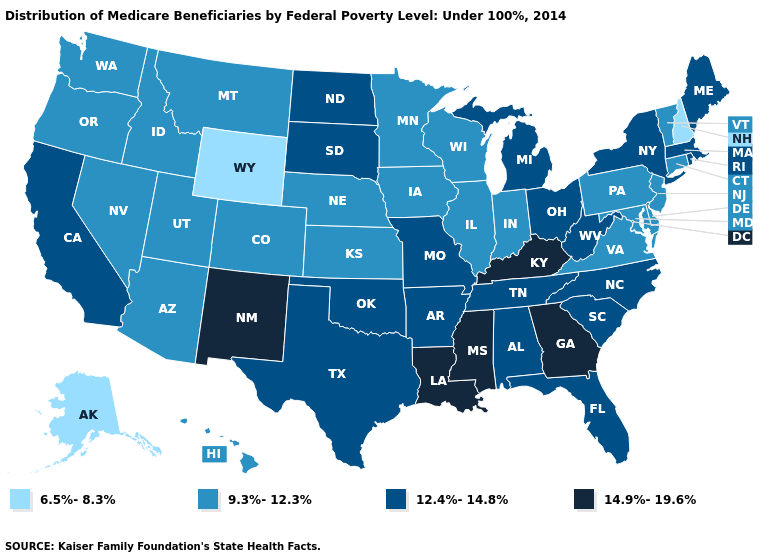Does Alaska have the highest value in the West?
Keep it brief. No. Does Hawaii have a lower value than Georgia?
Give a very brief answer. Yes. Among the states that border Virginia , does Kentucky have the highest value?
Be succinct. Yes. Which states have the lowest value in the USA?
Write a very short answer. Alaska, New Hampshire, Wyoming. Which states have the lowest value in the USA?
Short answer required. Alaska, New Hampshire, Wyoming. How many symbols are there in the legend?
Answer briefly. 4. What is the value of California?
Write a very short answer. 12.4%-14.8%. What is the lowest value in the Northeast?
Concise answer only. 6.5%-8.3%. Is the legend a continuous bar?
Be succinct. No. What is the highest value in the USA?
Concise answer only. 14.9%-19.6%. Name the states that have a value in the range 9.3%-12.3%?
Short answer required. Arizona, Colorado, Connecticut, Delaware, Hawaii, Idaho, Illinois, Indiana, Iowa, Kansas, Maryland, Minnesota, Montana, Nebraska, Nevada, New Jersey, Oregon, Pennsylvania, Utah, Vermont, Virginia, Washington, Wisconsin. Among the states that border Montana , which have the lowest value?
Keep it brief. Wyoming. Name the states that have a value in the range 6.5%-8.3%?
Short answer required. Alaska, New Hampshire, Wyoming. Name the states that have a value in the range 6.5%-8.3%?
Answer briefly. Alaska, New Hampshire, Wyoming. Does Kentucky have the highest value in the South?
Give a very brief answer. Yes. 